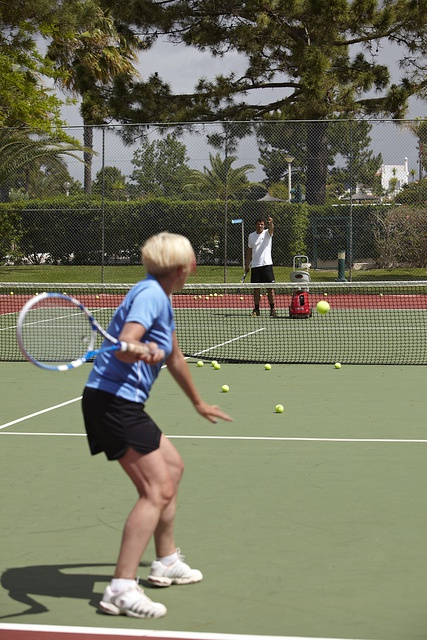Describe the objects in this image and their specific colors. I can see people in black, tan, and lightgray tones, tennis racket in black, darkgray, gray, and lightgray tones, people in black, darkgray, white, and gray tones, sports ball in black, brown, darkgray, and darkgreen tones, and sports ball in black, khaki, olive, and lightyellow tones in this image. 